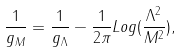Convert formula to latex. <formula><loc_0><loc_0><loc_500><loc_500>\frac { 1 } { g _ { M } } = \frac { 1 } { g _ { \Lambda } } - \frac { 1 } { 2 \pi } L o g ( \frac { \Lambda ^ { 2 } } { M ^ { 2 } } ) ,</formula> 